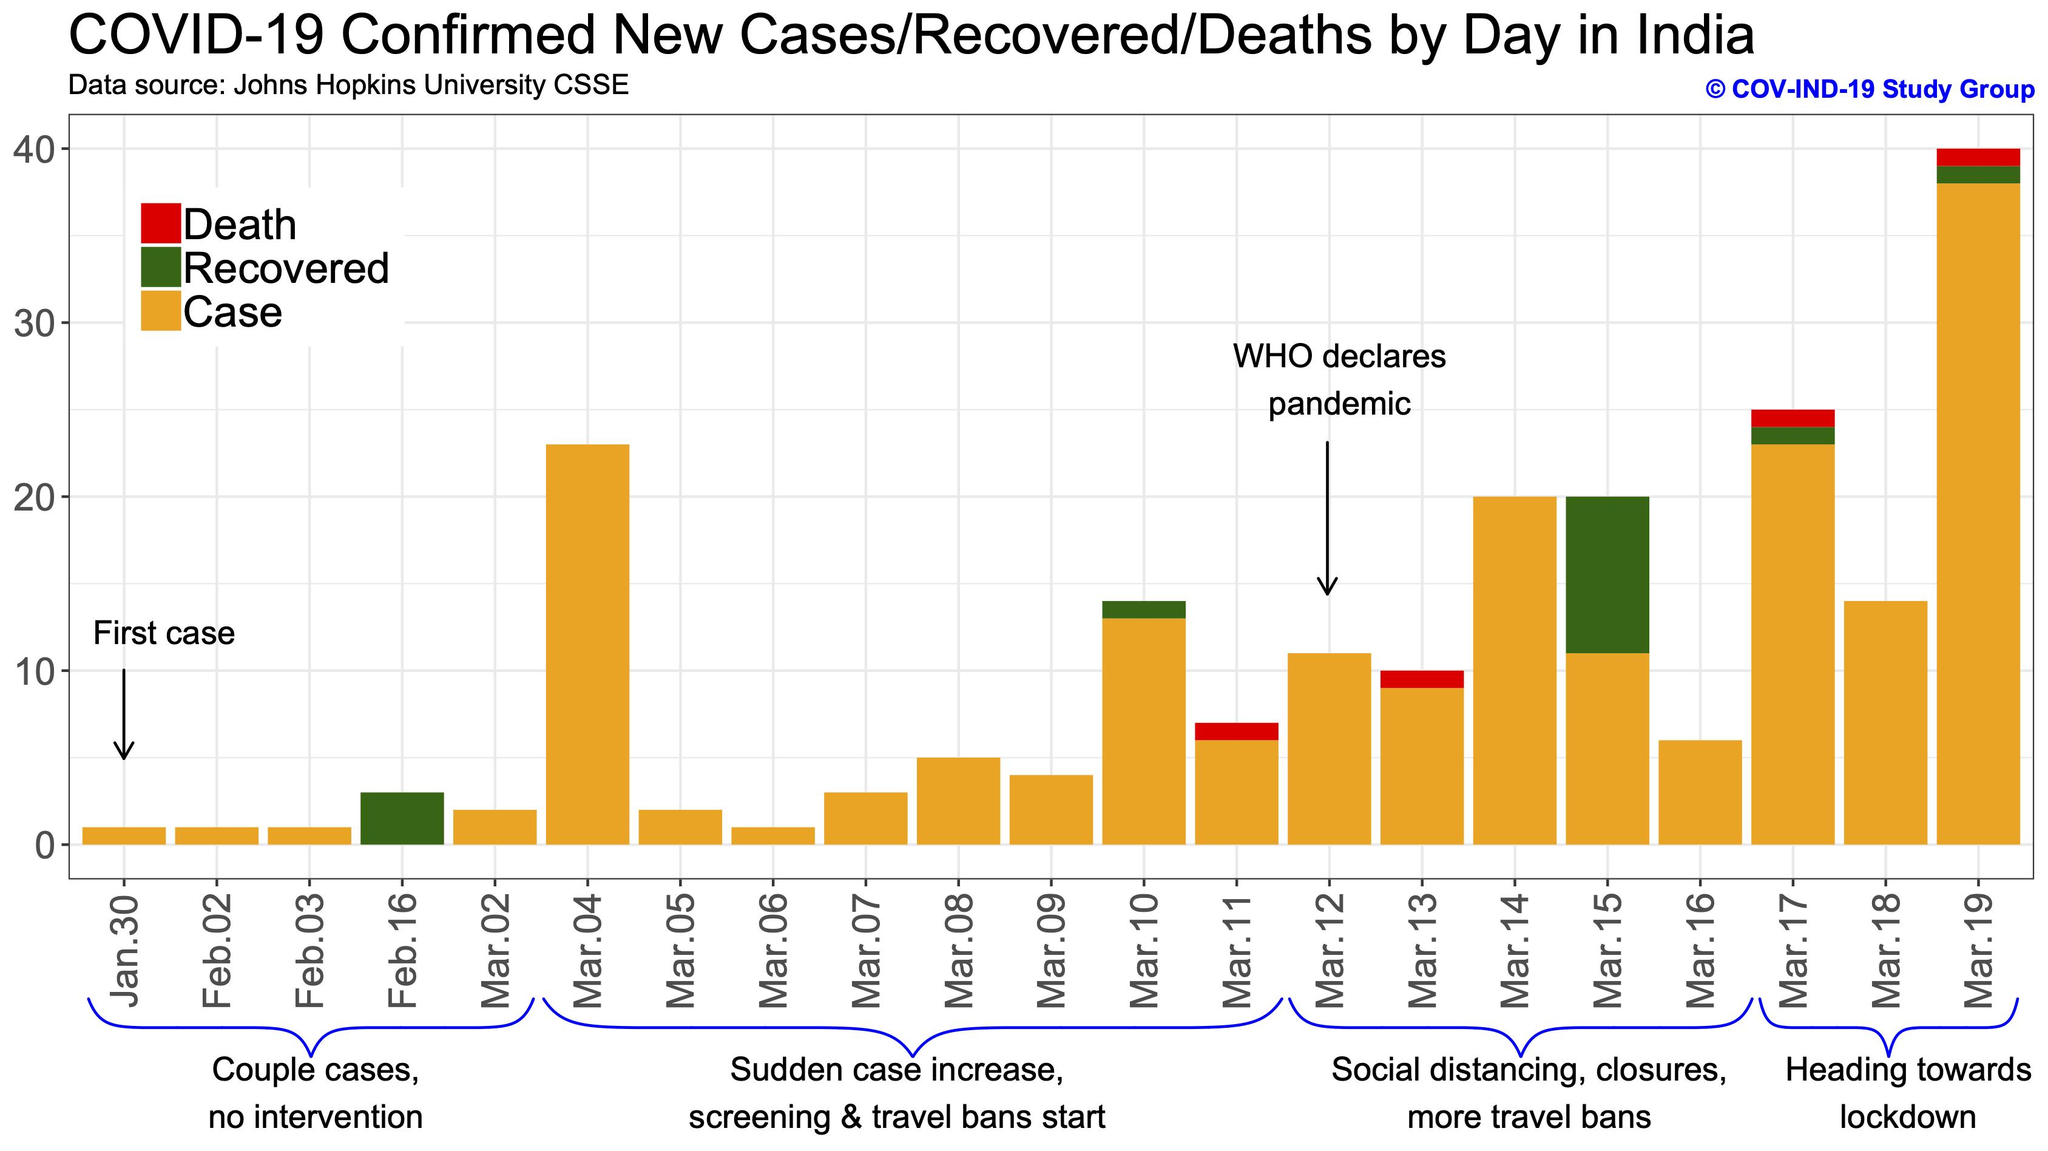List a handful of essential elements in this visual. On March 4th, a total of 23 cases were reported. The government decided to implement lockdown based on the data from Mar.17, Mar.18, and Mar.19. On June 11, 2020, the World Health Organization declared the COVID-19 pandemic. As of March 9th, a total of 4 cases have been reported. From January 30 to March 19, a total of 15 recovered cases were reported. 